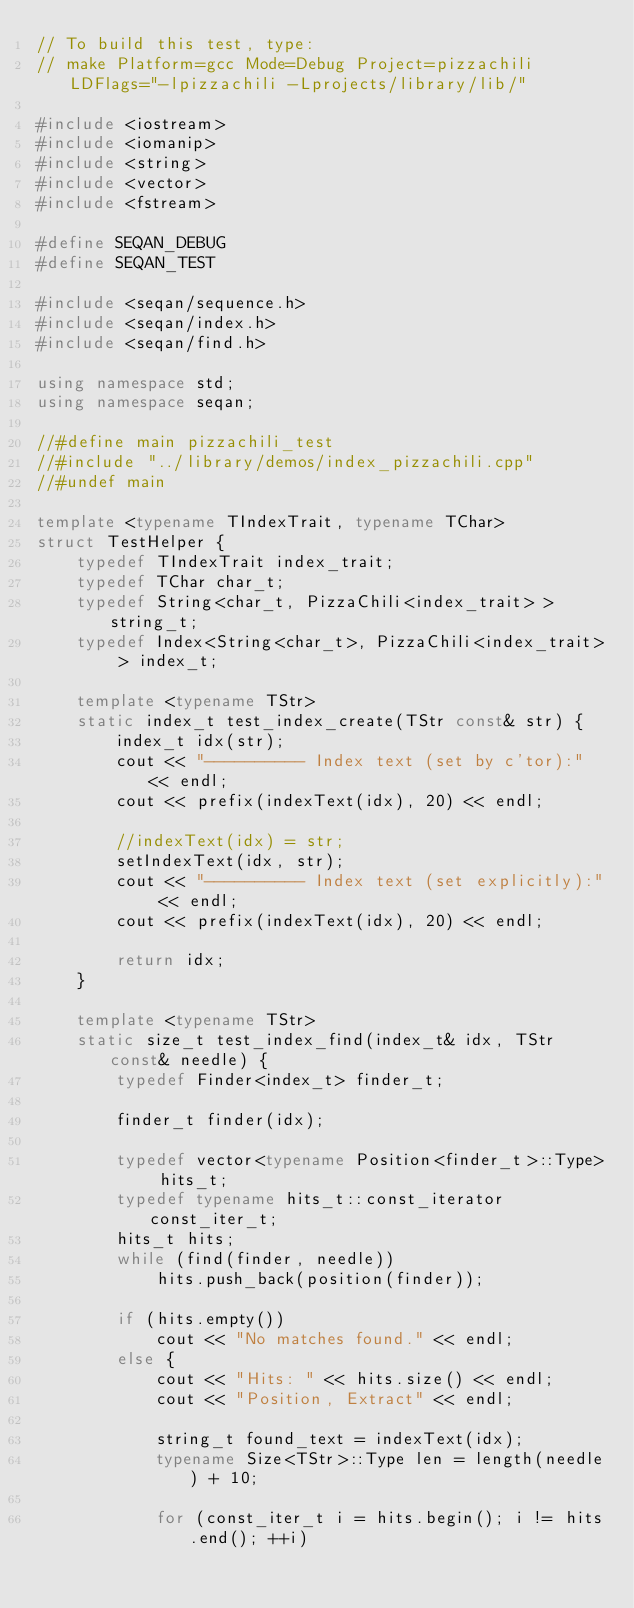<code> <loc_0><loc_0><loc_500><loc_500><_C++_>// To build this test, type:
// make Platform=gcc Mode=Debug Project=pizzachili LDFlags="-lpizzachili -Lprojects/library/lib/"

#include <iostream>
#include <iomanip>
#include <string>
#include <vector>
#include <fstream>

#define SEQAN_DEBUG
#define SEQAN_TEST

#include <seqan/sequence.h>
#include <seqan/index.h>
#include <seqan/find.h>

using namespace std;
using namespace seqan;

//#define main pizzachili_test
//#include "../library/demos/index_pizzachili.cpp"
//#undef main

template <typename TIndexTrait, typename TChar>
struct TestHelper {
    typedef TIndexTrait index_trait;
    typedef TChar char_t;
    typedef String<char_t, PizzaChili<index_trait> > string_t;
    typedef Index<String<char_t>, PizzaChili<index_trait> > index_t;

    template <typename TStr>
    static index_t test_index_create(TStr const& str) {
        index_t idx(str);
        cout << "---------- Index text (set by c'tor):" << endl;
        cout << prefix(indexText(idx), 20) << endl;
        
        //indexText(idx) = str;
        setIndexText(idx, str);
        cout << "---------- Index text (set explicitly):" << endl;
        cout << prefix(indexText(idx), 20) << endl;

        return idx;
    }

    template <typename TStr>
    static size_t test_index_find(index_t& idx, TStr const& needle) {
        typedef Finder<index_t> finder_t;

        finder_t finder(idx);

        typedef vector<typename Position<finder_t>::Type> hits_t;
        typedef typename hits_t::const_iterator const_iter_t;
        hits_t hits;
        while (find(finder, needle))
            hits.push_back(position(finder));

        if (hits.empty())
            cout << "No matches found." << endl;
        else {
            cout << "Hits: " << hits.size() << endl;
            cout << "Position, Extract" << endl;

            string_t found_text = indexText(idx);
            typename Size<TStr>::Type len = length(needle) + 10;

            for (const_iter_t i = hits.begin(); i != hits.end(); ++i)</code> 